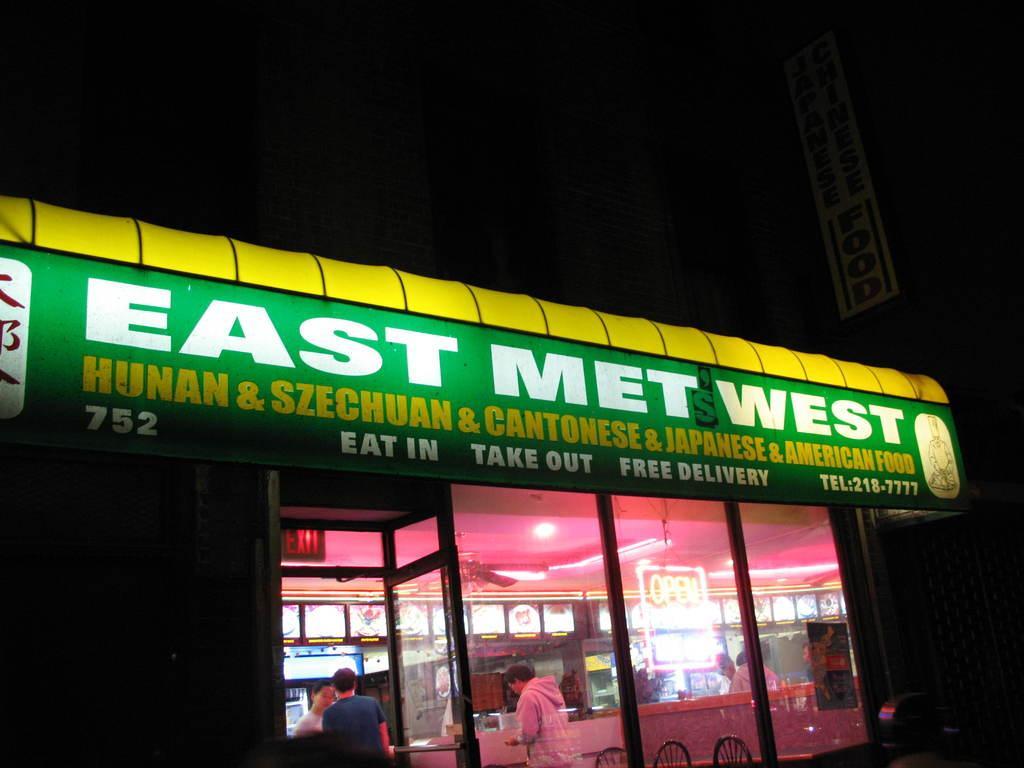Please provide a concise description of this image. In front of the image there is a shop. On top of it there is a board with some text and picture on it. Inside the shop there are people standing. There are chairs. There are display boards. On top of the image there is a fan. There are lights. Beside the shop there is a building with the board on it. 